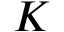Convert formula to latex. <formula><loc_0><loc_0><loc_500><loc_500>K</formula> 